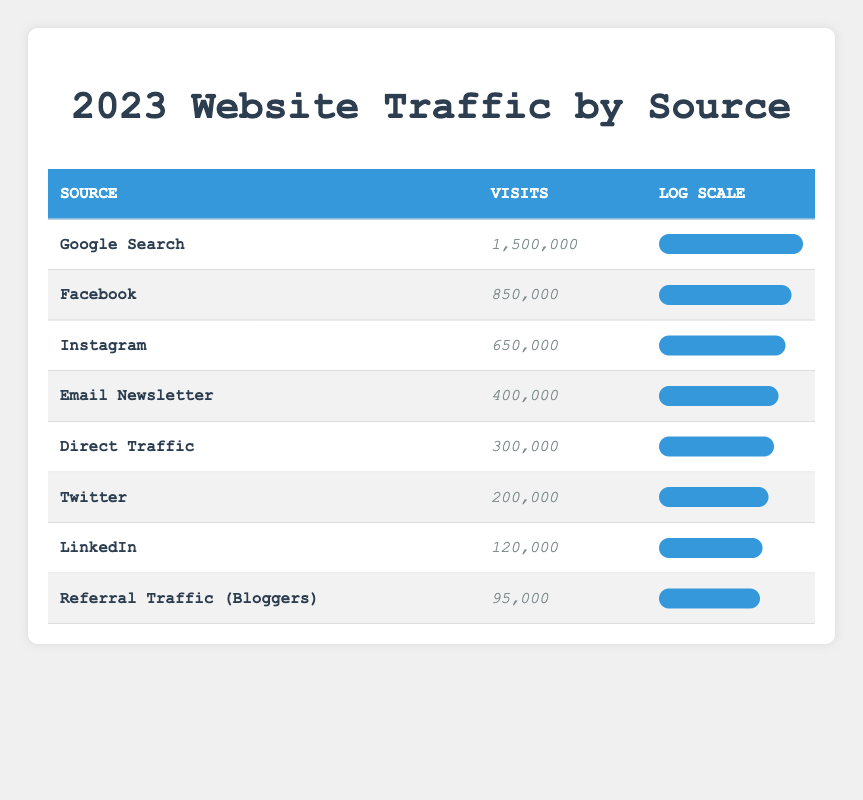What is the visit count from Google Search? The value for Google Search in the table is listed under "Visits" as 1,500,000.
Answer: 1,500,000 What is the source with the lowest number of visits? By checking the list of sources, Referral Traffic (Bloggers) has the lowest visits count at 95,000.
Answer: Referral Traffic (Bloggers) What is the visit count difference between Facebook and Email Newsletter? Facebook has 850,000 visits, Email Newsletter has 400,000 visits. The difference is 850,000 - 400,000 = 450,000.
Answer: 450,000 Is Direct Traffic greater than Twitter in terms of visits? Direct Traffic has 300,000 visits, while Twitter has 200,000 visits. Since 300,000 is greater than 200,000, the statement is true.
Answer: Yes What percentage of the total visits does Instagram represent? For total visits, we sum up all visits: 1,500,000 + 850,000 + 650,000 + 400,000 + 300,000 + 200,000 + 120,000 + 95,000 = 4,115,000. Instagram's visits are 650,000. The percentage is (650,000/4,115,000) * 100 = approximately 15.8%.
Answer: 15.8% How do the visits from Facebook and Instagram compare? Facebook has 850,000 visits and Instagram has 650,000 visits. The number of visits from Facebook is greater than Instagram's by 200,000.
Answer: Facebook has more visits Which source has a visit count greater than 400,000 but less than 800,000? Looking at each source, the only one that fits this range is Twitter which has 200,000, which does not fit, so the answer is no sources fall in this category.
Answer: No sources What is the average number of visits among all sources? To find the average, we first sum the visits: 1,500,000 + 850,000 + 650,000 + 400,000 + 300,000 + 200,000 + 120,000 + 95,000 = 4,115,000. There are 8 sources, therefore the average is 4,115,000/8 = 514,375.
Answer: 514,375 